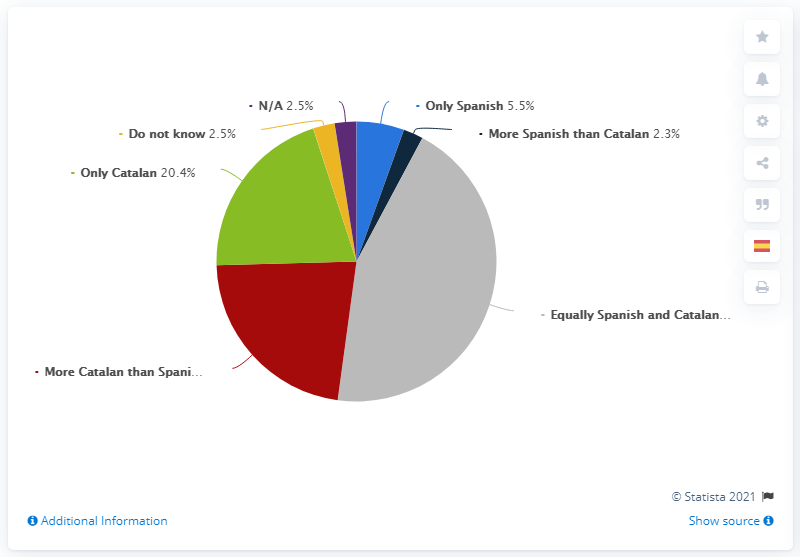Point out several critical features in this image. In July 2020, approximately 5.5% of the population in Catalonia strongly identified as Spanish. In July 2020, a share of 20.4% of people living in Catalonia self-identified as Only Catalan. 